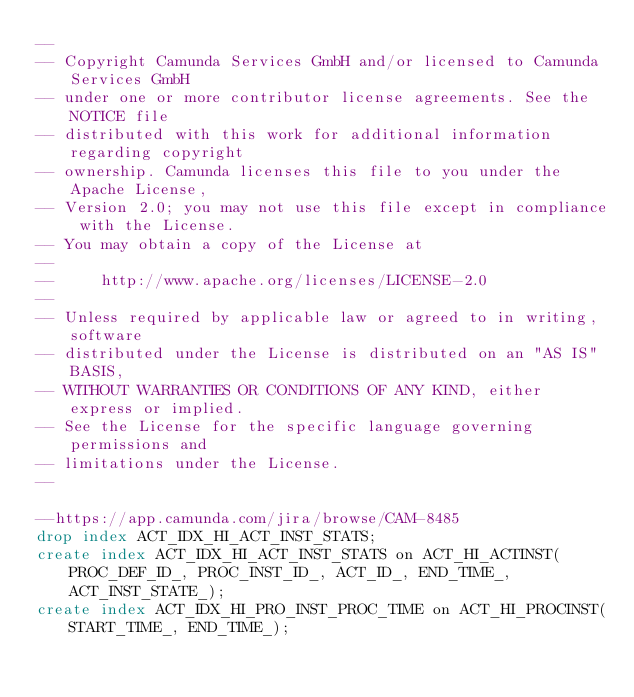Convert code to text. <code><loc_0><loc_0><loc_500><loc_500><_SQL_>--
-- Copyright Camunda Services GmbH and/or licensed to Camunda Services GmbH
-- under one or more contributor license agreements. See the NOTICE file
-- distributed with this work for additional information regarding copyright
-- ownership. Camunda licenses this file to you under the Apache License,
-- Version 2.0; you may not use this file except in compliance with the License.
-- You may obtain a copy of the License at
--
--     http://www.apache.org/licenses/LICENSE-2.0
--
-- Unless required by applicable law or agreed to in writing, software
-- distributed under the License is distributed on an "AS IS" BASIS,
-- WITHOUT WARRANTIES OR CONDITIONS OF ANY KIND, either express or implied.
-- See the License for the specific language governing permissions and
-- limitations under the License.
--

--https://app.camunda.com/jira/browse/CAM-8485
drop index ACT_IDX_HI_ACT_INST_STATS;
create index ACT_IDX_HI_ACT_INST_STATS on ACT_HI_ACTINST(PROC_DEF_ID_, PROC_INST_ID_, ACT_ID_, END_TIME_, ACT_INST_STATE_);
create index ACT_IDX_HI_PRO_INST_PROC_TIME on ACT_HI_PROCINST(START_TIME_, END_TIME_);
</code> 